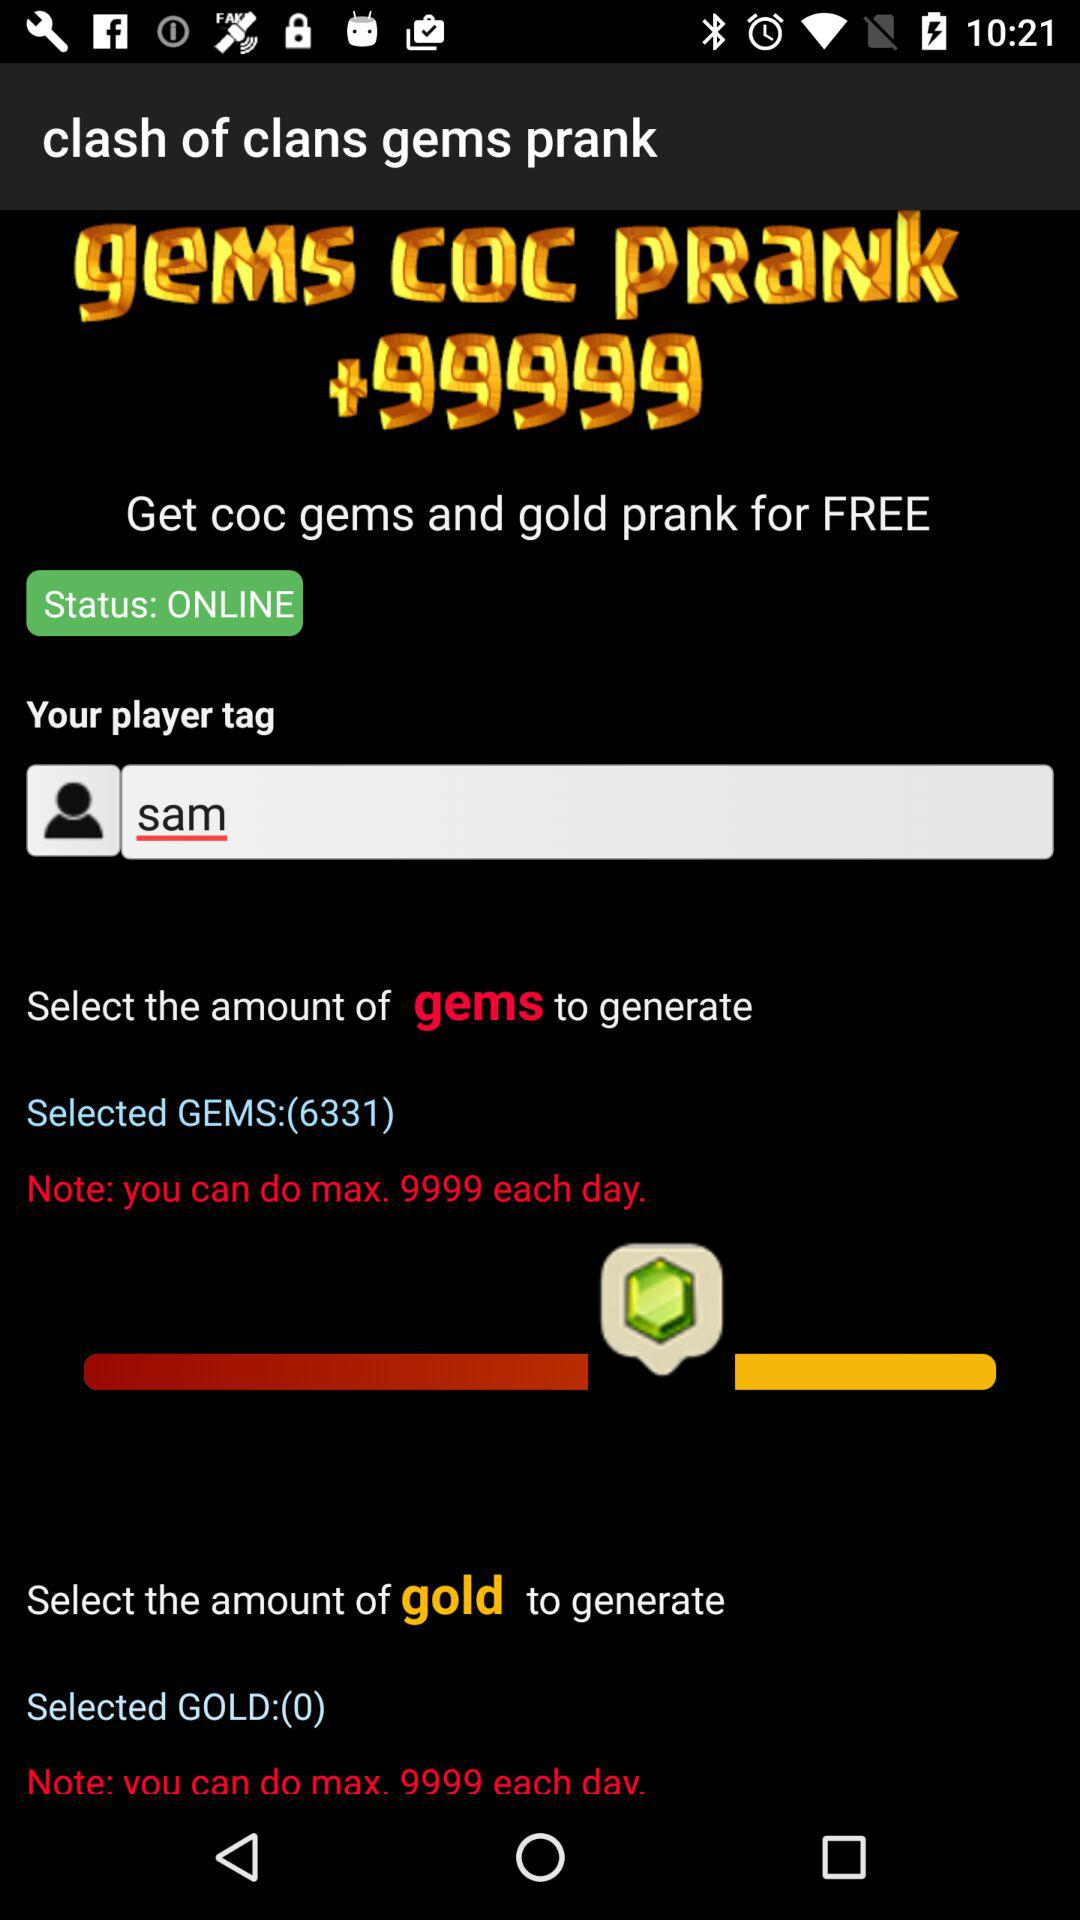What is the status? The status is "ONLINE". 